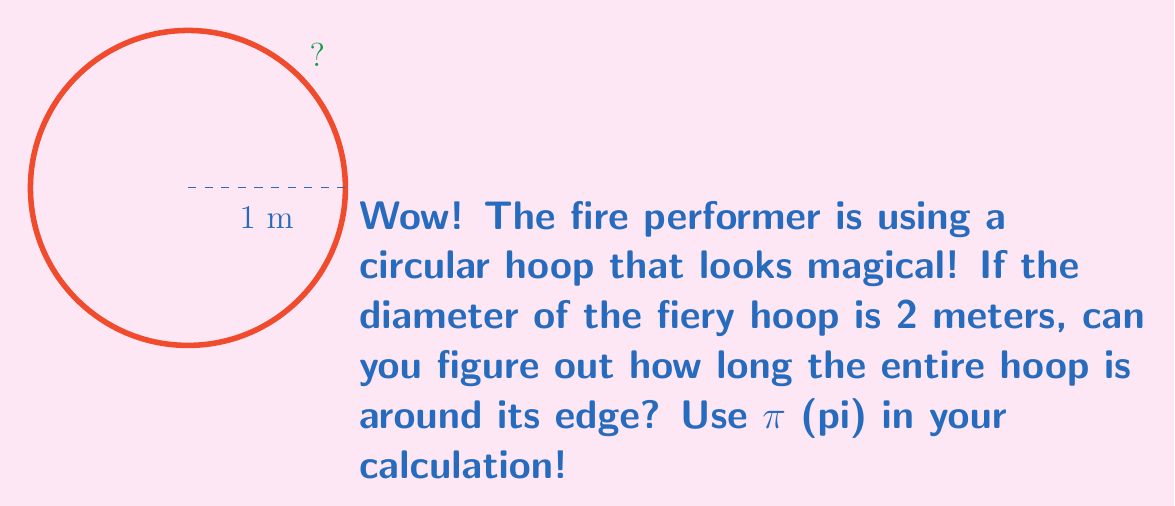Can you solve this math problem? Let's break this down step-by-step:

1) We know that the diameter of the hoop is 2 meters. The radius is half of this:
   $r = 2 \div 2 = 1$ meter

2) The formula for the circumference of a circle is:
   $$C = 2\pi r$$
   Where $C$ is the circumference, $\pi$ is pi, and $r$ is the radius.

3) Let's substitute our known value:
   $$C = 2\pi (1)$$

4) Simplify:
   $$C = 2\pi$$

5) We usually leave pi as π in the answer, but if we wanted to calculate it, we could use 3.14159 as an approximation:
   $$C \approx 2 * 3.14159 = 6.28318\text{ meters}$$
Answer: $2\pi$ meters 